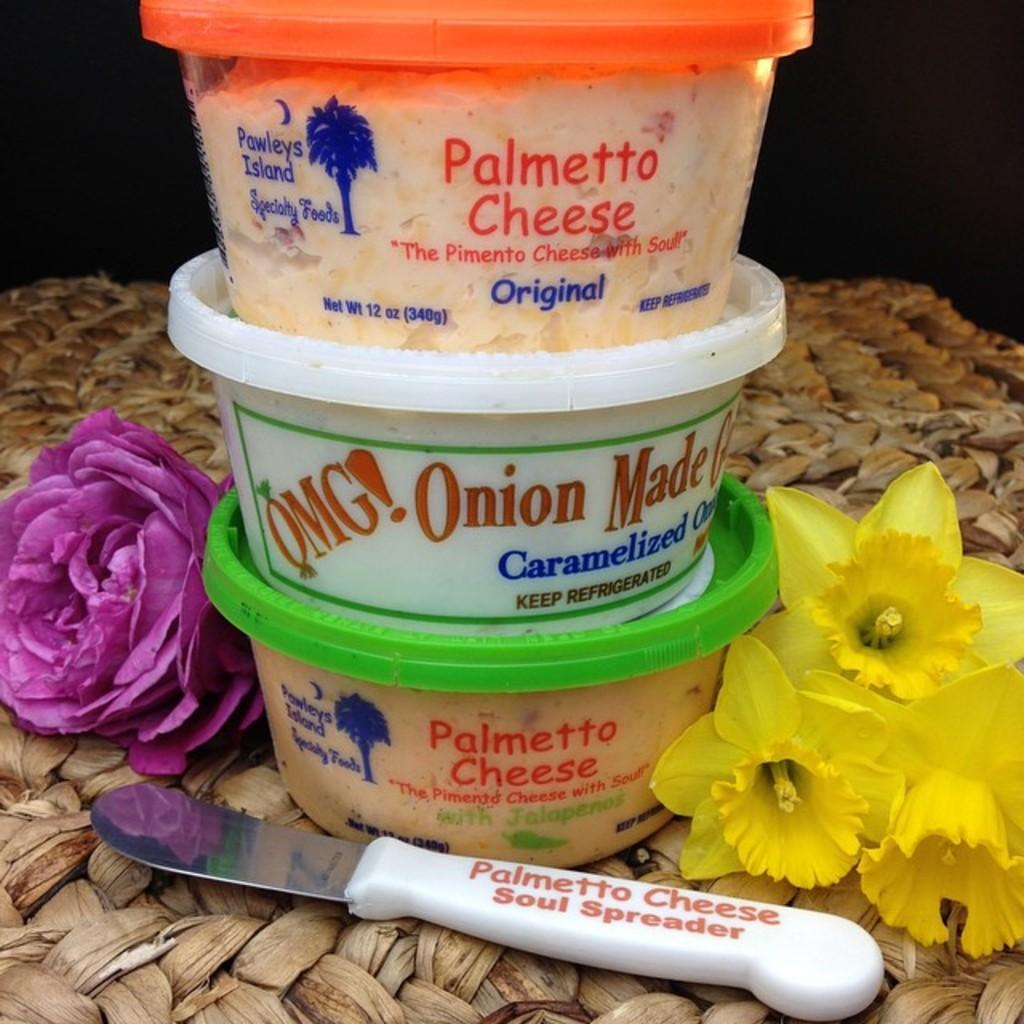Provide a one-sentence caption for the provided image. three containers of Palmetto Cheese, OMG! Carmelized Onions, and a Palmetto Cheese Soul Spreader. 